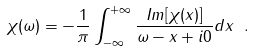Convert formula to latex. <formula><loc_0><loc_0><loc_500><loc_500>\chi ( \omega ) = - \frac { 1 } { \pi } \int _ { - \infty } ^ { + \infty } \frac { I m [ \chi ( x ) ] } { \omega - x + i 0 } d x \ .</formula> 